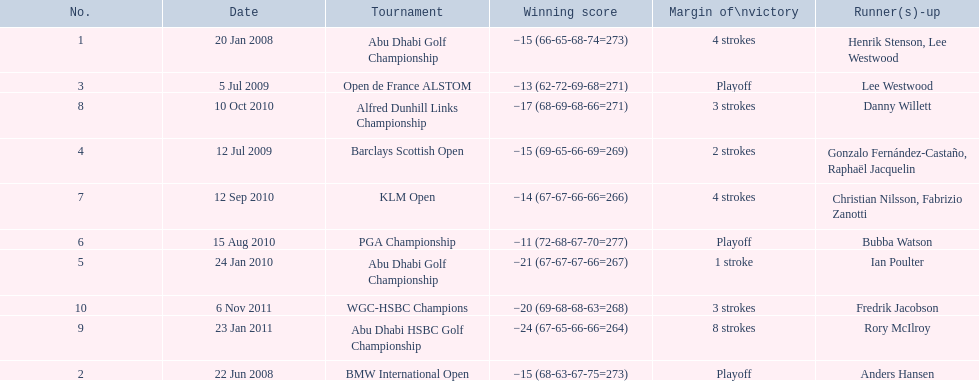How many total tournaments has he won? 10. 